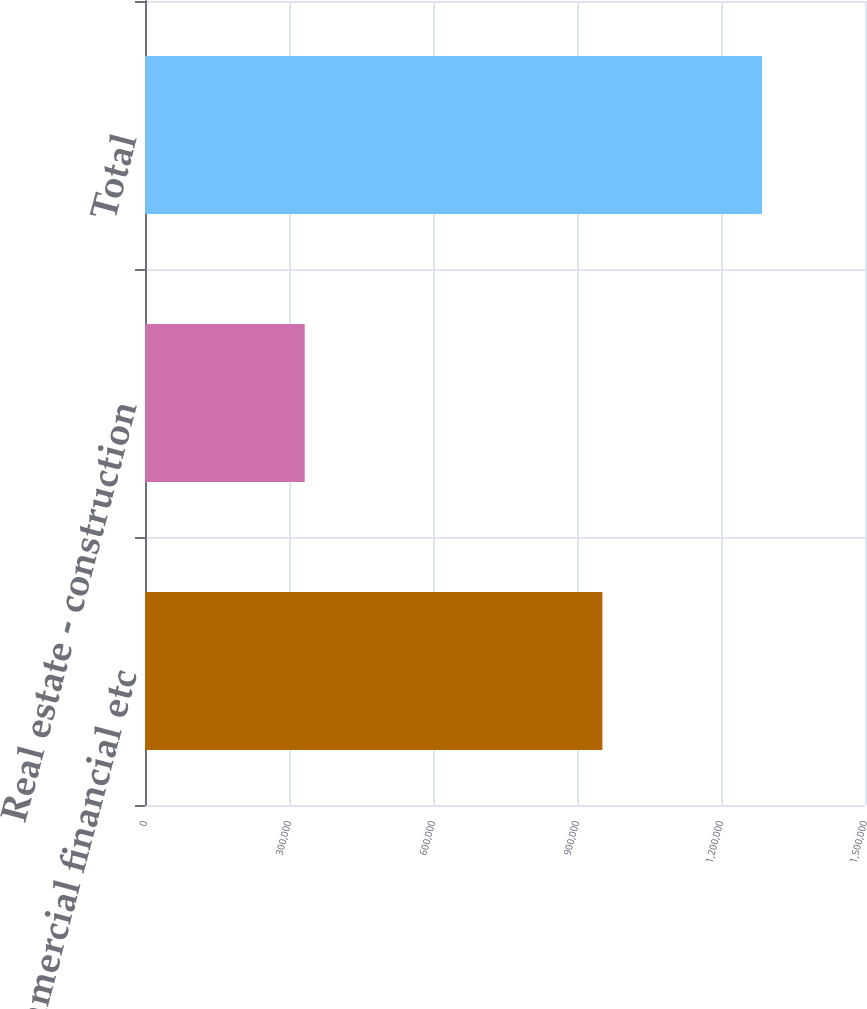Convert chart to OTSL. <chart><loc_0><loc_0><loc_500><loc_500><bar_chart><fcel>Commercial financial etc<fcel>Real estate - construction<fcel>Total<nl><fcel>952949<fcel>332725<fcel>1.28567e+06<nl></chart> 